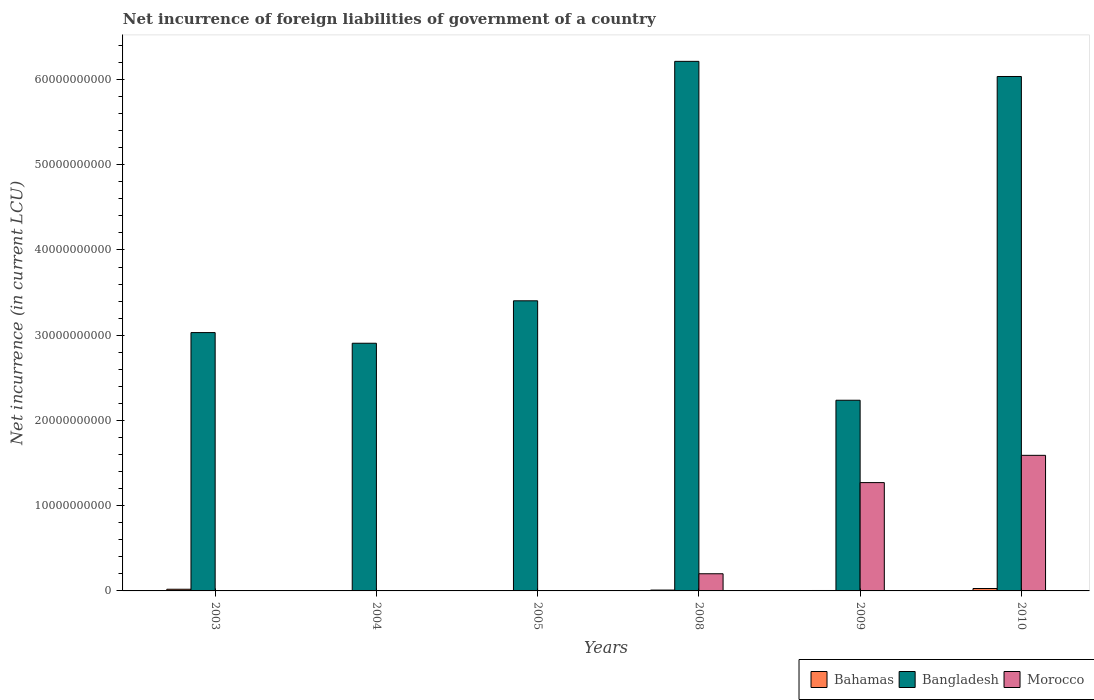Are the number of bars on each tick of the X-axis equal?
Your answer should be compact. No. How many bars are there on the 4th tick from the left?
Make the answer very short. 3. In how many cases, is the number of bars for a given year not equal to the number of legend labels?
Give a very brief answer. 3. What is the net incurrence of foreign liabilities in Bangladesh in 2010?
Make the answer very short. 6.04e+1. Across all years, what is the maximum net incurrence of foreign liabilities in Morocco?
Your answer should be compact. 1.59e+1. Across all years, what is the minimum net incurrence of foreign liabilities in Bahamas?
Your answer should be very brief. 0. What is the total net incurrence of foreign liabilities in Bangladesh in the graph?
Your response must be concise. 2.38e+11. What is the difference between the net incurrence of foreign liabilities in Bangladesh in 2004 and that in 2005?
Give a very brief answer. -4.98e+09. What is the difference between the net incurrence of foreign liabilities in Morocco in 2005 and the net incurrence of foreign liabilities in Bangladesh in 2009?
Ensure brevity in your answer.  -2.24e+1. What is the average net incurrence of foreign liabilities in Bangladesh per year?
Make the answer very short. 3.97e+1. In the year 2009, what is the difference between the net incurrence of foreign liabilities in Morocco and net incurrence of foreign liabilities in Bahamas?
Make the answer very short. 1.27e+1. What is the ratio of the net incurrence of foreign liabilities in Bangladesh in 2008 to that in 2009?
Your answer should be compact. 2.78. What is the difference between the highest and the second highest net incurrence of foreign liabilities in Morocco?
Your response must be concise. 3.20e+09. What is the difference between the highest and the lowest net incurrence of foreign liabilities in Bangladesh?
Provide a short and direct response. 3.98e+1. In how many years, is the net incurrence of foreign liabilities in Morocco greater than the average net incurrence of foreign liabilities in Morocco taken over all years?
Give a very brief answer. 2. Is the sum of the net incurrence of foreign liabilities in Bahamas in 2008 and 2010 greater than the maximum net incurrence of foreign liabilities in Bangladesh across all years?
Your answer should be compact. No. Are all the bars in the graph horizontal?
Make the answer very short. No. Does the graph contain any zero values?
Offer a very short reply. Yes. How many legend labels are there?
Provide a short and direct response. 3. What is the title of the graph?
Ensure brevity in your answer.  Net incurrence of foreign liabilities of government of a country. What is the label or title of the X-axis?
Your response must be concise. Years. What is the label or title of the Y-axis?
Keep it short and to the point. Net incurrence (in current LCU). What is the Net incurrence (in current LCU) in Bahamas in 2003?
Give a very brief answer. 1.97e+08. What is the Net incurrence (in current LCU) of Bangladesh in 2003?
Your answer should be compact. 3.03e+1. What is the Net incurrence (in current LCU) in Bahamas in 2004?
Ensure brevity in your answer.  0. What is the Net incurrence (in current LCU) in Bangladesh in 2004?
Your answer should be compact. 2.91e+1. What is the Net incurrence (in current LCU) of Morocco in 2004?
Your response must be concise. 0. What is the Net incurrence (in current LCU) of Bahamas in 2005?
Keep it short and to the point. 1.70e+06. What is the Net incurrence (in current LCU) of Bangladesh in 2005?
Keep it short and to the point. 3.40e+1. What is the Net incurrence (in current LCU) of Bangladesh in 2008?
Your response must be concise. 6.21e+1. What is the Net incurrence (in current LCU) of Morocco in 2008?
Make the answer very short. 2.01e+09. What is the Net incurrence (in current LCU) in Bahamas in 2009?
Your answer should be very brief. 5.02e+07. What is the Net incurrence (in current LCU) of Bangladesh in 2009?
Your response must be concise. 2.24e+1. What is the Net incurrence (in current LCU) in Morocco in 2009?
Offer a very short reply. 1.27e+1. What is the Net incurrence (in current LCU) of Bahamas in 2010?
Keep it short and to the point. 2.83e+08. What is the Net incurrence (in current LCU) of Bangladesh in 2010?
Give a very brief answer. 6.04e+1. What is the Net incurrence (in current LCU) in Morocco in 2010?
Your response must be concise. 1.59e+1. Across all years, what is the maximum Net incurrence (in current LCU) in Bahamas?
Your answer should be compact. 2.83e+08. Across all years, what is the maximum Net incurrence (in current LCU) in Bangladesh?
Offer a terse response. 6.21e+1. Across all years, what is the maximum Net incurrence (in current LCU) of Morocco?
Keep it short and to the point. 1.59e+1. Across all years, what is the minimum Net incurrence (in current LCU) in Bahamas?
Provide a succinct answer. 0. Across all years, what is the minimum Net incurrence (in current LCU) in Bangladesh?
Provide a short and direct response. 2.24e+1. What is the total Net incurrence (in current LCU) in Bahamas in the graph?
Make the answer very short. 6.32e+08. What is the total Net incurrence (in current LCU) of Bangladesh in the graph?
Keep it short and to the point. 2.38e+11. What is the total Net incurrence (in current LCU) in Morocco in the graph?
Ensure brevity in your answer.  3.06e+1. What is the difference between the Net incurrence (in current LCU) of Bangladesh in 2003 and that in 2004?
Provide a short and direct response. 1.25e+09. What is the difference between the Net incurrence (in current LCU) in Bahamas in 2003 and that in 2005?
Offer a very short reply. 1.95e+08. What is the difference between the Net incurrence (in current LCU) of Bangladesh in 2003 and that in 2005?
Make the answer very short. -3.73e+09. What is the difference between the Net incurrence (in current LCU) in Bahamas in 2003 and that in 2008?
Your response must be concise. 9.71e+07. What is the difference between the Net incurrence (in current LCU) in Bangladesh in 2003 and that in 2008?
Your response must be concise. -3.18e+1. What is the difference between the Net incurrence (in current LCU) in Bahamas in 2003 and that in 2009?
Give a very brief answer. 1.47e+08. What is the difference between the Net incurrence (in current LCU) in Bangladesh in 2003 and that in 2009?
Ensure brevity in your answer.  7.94e+09. What is the difference between the Net incurrence (in current LCU) in Bahamas in 2003 and that in 2010?
Your answer should be compact. -8.59e+07. What is the difference between the Net incurrence (in current LCU) in Bangladesh in 2003 and that in 2010?
Make the answer very short. -3.00e+1. What is the difference between the Net incurrence (in current LCU) of Bangladesh in 2004 and that in 2005?
Give a very brief answer. -4.98e+09. What is the difference between the Net incurrence (in current LCU) of Bangladesh in 2004 and that in 2008?
Your answer should be compact. -3.31e+1. What is the difference between the Net incurrence (in current LCU) in Bangladesh in 2004 and that in 2009?
Provide a succinct answer. 6.69e+09. What is the difference between the Net incurrence (in current LCU) in Bangladesh in 2004 and that in 2010?
Provide a succinct answer. -3.13e+1. What is the difference between the Net incurrence (in current LCU) of Bahamas in 2005 and that in 2008?
Provide a short and direct response. -9.83e+07. What is the difference between the Net incurrence (in current LCU) in Bangladesh in 2005 and that in 2008?
Ensure brevity in your answer.  -2.81e+1. What is the difference between the Net incurrence (in current LCU) of Bahamas in 2005 and that in 2009?
Your answer should be very brief. -4.85e+07. What is the difference between the Net incurrence (in current LCU) of Bangladesh in 2005 and that in 2009?
Keep it short and to the point. 1.17e+1. What is the difference between the Net incurrence (in current LCU) of Bahamas in 2005 and that in 2010?
Keep it short and to the point. -2.81e+08. What is the difference between the Net incurrence (in current LCU) of Bangladesh in 2005 and that in 2010?
Provide a short and direct response. -2.63e+1. What is the difference between the Net incurrence (in current LCU) in Bahamas in 2008 and that in 2009?
Offer a terse response. 4.98e+07. What is the difference between the Net incurrence (in current LCU) of Bangladesh in 2008 and that in 2009?
Give a very brief answer. 3.98e+1. What is the difference between the Net incurrence (in current LCU) of Morocco in 2008 and that in 2009?
Provide a short and direct response. -1.07e+1. What is the difference between the Net incurrence (in current LCU) in Bahamas in 2008 and that in 2010?
Provide a short and direct response. -1.83e+08. What is the difference between the Net incurrence (in current LCU) in Bangladesh in 2008 and that in 2010?
Give a very brief answer. 1.78e+09. What is the difference between the Net incurrence (in current LCU) of Morocco in 2008 and that in 2010?
Provide a succinct answer. -1.39e+1. What is the difference between the Net incurrence (in current LCU) of Bahamas in 2009 and that in 2010?
Your answer should be compact. -2.33e+08. What is the difference between the Net incurrence (in current LCU) of Bangladesh in 2009 and that in 2010?
Offer a very short reply. -3.80e+1. What is the difference between the Net incurrence (in current LCU) of Morocco in 2009 and that in 2010?
Your answer should be very brief. -3.20e+09. What is the difference between the Net incurrence (in current LCU) of Bahamas in 2003 and the Net incurrence (in current LCU) of Bangladesh in 2004?
Provide a succinct answer. -2.89e+1. What is the difference between the Net incurrence (in current LCU) of Bahamas in 2003 and the Net incurrence (in current LCU) of Bangladesh in 2005?
Your response must be concise. -3.38e+1. What is the difference between the Net incurrence (in current LCU) of Bahamas in 2003 and the Net incurrence (in current LCU) of Bangladesh in 2008?
Make the answer very short. -6.19e+1. What is the difference between the Net incurrence (in current LCU) of Bahamas in 2003 and the Net incurrence (in current LCU) of Morocco in 2008?
Your response must be concise. -1.82e+09. What is the difference between the Net incurrence (in current LCU) of Bangladesh in 2003 and the Net incurrence (in current LCU) of Morocco in 2008?
Give a very brief answer. 2.83e+1. What is the difference between the Net incurrence (in current LCU) of Bahamas in 2003 and the Net incurrence (in current LCU) of Bangladesh in 2009?
Keep it short and to the point. -2.22e+1. What is the difference between the Net incurrence (in current LCU) in Bahamas in 2003 and the Net incurrence (in current LCU) in Morocco in 2009?
Your answer should be compact. -1.25e+1. What is the difference between the Net incurrence (in current LCU) in Bangladesh in 2003 and the Net incurrence (in current LCU) in Morocco in 2009?
Make the answer very short. 1.76e+1. What is the difference between the Net incurrence (in current LCU) of Bahamas in 2003 and the Net incurrence (in current LCU) of Bangladesh in 2010?
Offer a terse response. -6.02e+1. What is the difference between the Net incurrence (in current LCU) of Bahamas in 2003 and the Net incurrence (in current LCU) of Morocco in 2010?
Give a very brief answer. -1.57e+1. What is the difference between the Net incurrence (in current LCU) of Bangladesh in 2003 and the Net incurrence (in current LCU) of Morocco in 2010?
Offer a terse response. 1.44e+1. What is the difference between the Net incurrence (in current LCU) of Bangladesh in 2004 and the Net incurrence (in current LCU) of Morocco in 2008?
Ensure brevity in your answer.  2.70e+1. What is the difference between the Net incurrence (in current LCU) in Bangladesh in 2004 and the Net incurrence (in current LCU) in Morocco in 2009?
Keep it short and to the point. 1.64e+1. What is the difference between the Net incurrence (in current LCU) of Bangladesh in 2004 and the Net incurrence (in current LCU) of Morocco in 2010?
Your answer should be very brief. 1.32e+1. What is the difference between the Net incurrence (in current LCU) in Bahamas in 2005 and the Net incurrence (in current LCU) in Bangladesh in 2008?
Your answer should be compact. -6.21e+1. What is the difference between the Net incurrence (in current LCU) in Bahamas in 2005 and the Net incurrence (in current LCU) in Morocco in 2008?
Ensure brevity in your answer.  -2.01e+09. What is the difference between the Net incurrence (in current LCU) of Bangladesh in 2005 and the Net incurrence (in current LCU) of Morocco in 2008?
Ensure brevity in your answer.  3.20e+1. What is the difference between the Net incurrence (in current LCU) of Bahamas in 2005 and the Net incurrence (in current LCU) of Bangladesh in 2009?
Make the answer very short. -2.24e+1. What is the difference between the Net incurrence (in current LCU) in Bahamas in 2005 and the Net incurrence (in current LCU) in Morocco in 2009?
Provide a short and direct response. -1.27e+1. What is the difference between the Net incurrence (in current LCU) in Bangladesh in 2005 and the Net incurrence (in current LCU) in Morocco in 2009?
Provide a short and direct response. 2.13e+1. What is the difference between the Net incurrence (in current LCU) in Bahamas in 2005 and the Net incurrence (in current LCU) in Bangladesh in 2010?
Keep it short and to the point. -6.04e+1. What is the difference between the Net incurrence (in current LCU) of Bahamas in 2005 and the Net incurrence (in current LCU) of Morocco in 2010?
Offer a very short reply. -1.59e+1. What is the difference between the Net incurrence (in current LCU) of Bangladesh in 2005 and the Net incurrence (in current LCU) of Morocco in 2010?
Keep it short and to the point. 1.81e+1. What is the difference between the Net incurrence (in current LCU) of Bahamas in 2008 and the Net incurrence (in current LCU) of Bangladesh in 2009?
Your response must be concise. -2.23e+1. What is the difference between the Net incurrence (in current LCU) in Bahamas in 2008 and the Net incurrence (in current LCU) in Morocco in 2009?
Provide a short and direct response. -1.26e+1. What is the difference between the Net incurrence (in current LCU) in Bangladesh in 2008 and the Net incurrence (in current LCU) in Morocco in 2009?
Provide a succinct answer. 4.94e+1. What is the difference between the Net incurrence (in current LCU) in Bahamas in 2008 and the Net incurrence (in current LCU) in Bangladesh in 2010?
Your response must be concise. -6.03e+1. What is the difference between the Net incurrence (in current LCU) in Bahamas in 2008 and the Net incurrence (in current LCU) in Morocco in 2010?
Provide a short and direct response. -1.58e+1. What is the difference between the Net incurrence (in current LCU) in Bangladesh in 2008 and the Net incurrence (in current LCU) in Morocco in 2010?
Your response must be concise. 4.62e+1. What is the difference between the Net incurrence (in current LCU) of Bahamas in 2009 and the Net incurrence (in current LCU) of Bangladesh in 2010?
Keep it short and to the point. -6.03e+1. What is the difference between the Net incurrence (in current LCU) in Bahamas in 2009 and the Net incurrence (in current LCU) in Morocco in 2010?
Give a very brief answer. -1.59e+1. What is the difference between the Net incurrence (in current LCU) in Bangladesh in 2009 and the Net incurrence (in current LCU) in Morocco in 2010?
Offer a terse response. 6.46e+09. What is the average Net incurrence (in current LCU) in Bahamas per year?
Make the answer very short. 1.05e+08. What is the average Net incurrence (in current LCU) in Bangladesh per year?
Keep it short and to the point. 3.97e+1. What is the average Net incurrence (in current LCU) of Morocco per year?
Keep it short and to the point. 5.10e+09. In the year 2003, what is the difference between the Net incurrence (in current LCU) in Bahamas and Net incurrence (in current LCU) in Bangladesh?
Provide a succinct answer. -3.01e+1. In the year 2005, what is the difference between the Net incurrence (in current LCU) in Bahamas and Net incurrence (in current LCU) in Bangladesh?
Make the answer very short. -3.40e+1. In the year 2008, what is the difference between the Net incurrence (in current LCU) of Bahamas and Net incurrence (in current LCU) of Bangladesh?
Provide a short and direct response. -6.20e+1. In the year 2008, what is the difference between the Net incurrence (in current LCU) of Bahamas and Net incurrence (in current LCU) of Morocco?
Your answer should be very brief. -1.91e+09. In the year 2008, what is the difference between the Net incurrence (in current LCU) of Bangladesh and Net incurrence (in current LCU) of Morocco?
Ensure brevity in your answer.  6.01e+1. In the year 2009, what is the difference between the Net incurrence (in current LCU) in Bahamas and Net incurrence (in current LCU) in Bangladesh?
Give a very brief answer. -2.23e+1. In the year 2009, what is the difference between the Net incurrence (in current LCU) of Bahamas and Net incurrence (in current LCU) of Morocco?
Offer a very short reply. -1.27e+1. In the year 2009, what is the difference between the Net incurrence (in current LCU) in Bangladesh and Net incurrence (in current LCU) in Morocco?
Give a very brief answer. 9.66e+09. In the year 2010, what is the difference between the Net incurrence (in current LCU) in Bahamas and Net incurrence (in current LCU) in Bangladesh?
Provide a short and direct response. -6.01e+1. In the year 2010, what is the difference between the Net incurrence (in current LCU) of Bahamas and Net incurrence (in current LCU) of Morocco?
Offer a very short reply. -1.56e+1. In the year 2010, what is the difference between the Net incurrence (in current LCU) of Bangladesh and Net incurrence (in current LCU) of Morocco?
Provide a succinct answer. 4.44e+1. What is the ratio of the Net incurrence (in current LCU) of Bangladesh in 2003 to that in 2004?
Your answer should be compact. 1.04. What is the ratio of the Net incurrence (in current LCU) in Bahamas in 2003 to that in 2005?
Your answer should be very brief. 115.94. What is the ratio of the Net incurrence (in current LCU) in Bangladesh in 2003 to that in 2005?
Your answer should be very brief. 0.89. What is the ratio of the Net incurrence (in current LCU) in Bahamas in 2003 to that in 2008?
Your response must be concise. 1.97. What is the ratio of the Net incurrence (in current LCU) in Bangladesh in 2003 to that in 2008?
Keep it short and to the point. 0.49. What is the ratio of the Net incurrence (in current LCU) of Bahamas in 2003 to that in 2009?
Your answer should be very brief. 3.93. What is the ratio of the Net incurrence (in current LCU) in Bangladesh in 2003 to that in 2009?
Your answer should be compact. 1.35. What is the ratio of the Net incurrence (in current LCU) in Bahamas in 2003 to that in 2010?
Keep it short and to the point. 0.7. What is the ratio of the Net incurrence (in current LCU) in Bangladesh in 2003 to that in 2010?
Make the answer very short. 0.5. What is the ratio of the Net incurrence (in current LCU) in Bangladesh in 2004 to that in 2005?
Provide a succinct answer. 0.85. What is the ratio of the Net incurrence (in current LCU) of Bangladesh in 2004 to that in 2008?
Provide a short and direct response. 0.47. What is the ratio of the Net incurrence (in current LCU) in Bangladesh in 2004 to that in 2009?
Provide a short and direct response. 1.3. What is the ratio of the Net incurrence (in current LCU) in Bangladesh in 2004 to that in 2010?
Offer a very short reply. 0.48. What is the ratio of the Net incurrence (in current LCU) in Bahamas in 2005 to that in 2008?
Offer a very short reply. 0.02. What is the ratio of the Net incurrence (in current LCU) of Bangladesh in 2005 to that in 2008?
Your response must be concise. 0.55. What is the ratio of the Net incurrence (in current LCU) of Bahamas in 2005 to that in 2009?
Your response must be concise. 0.03. What is the ratio of the Net incurrence (in current LCU) of Bangladesh in 2005 to that in 2009?
Your answer should be very brief. 1.52. What is the ratio of the Net incurrence (in current LCU) in Bahamas in 2005 to that in 2010?
Give a very brief answer. 0.01. What is the ratio of the Net incurrence (in current LCU) of Bangladesh in 2005 to that in 2010?
Ensure brevity in your answer.  0.56. What is the ratio of the Net incurrence (in current LCU) of Bahamas in 2008 to that in 2009?
Provide a succinct answer. 1.99. What is the ratio of the Net incurrence (in current LCU) of Bangladesh in 2008 to that in 2009?
Provide a succinct answer. 2.78. What is the ratio of the Net incurrence (in current LCU) in Morocco in 2008 to that in 2009?
Offer a terse response. 0.16. What is the ratio of the Net incurrence (in current LCU) in Bahamas in 2008 to that in 2010?
Ensure brevity in your answer.  0.35. What is the ratio of the Net incurrence (in current LCU) in Bangladesh in 2008 to that in 2010?
Your answer should be very brief. 1.03. What is the ratio of the Net incurrence (in current LCU) in Morocco in 2008 to that in 2010?
Give a very brief answer. 0.13. What is the ratio of the Net incurrence (in current LCU) of Bahamas in 2009 to that in 2010?
Provide a succinct answer. 0.18. What is the ratio of the Net incurrence (in current LCU) of Bangladesh in 2009 to that in 2010?
Ensure brevity in your answer.  0.37. What is the ratio of the Net incurrence (in current LCU) of Morocco in 2009 to that in 2010?
Your answer should be compact. 0.8. What is the difference between the highest and the second highest Net incurrence (in current LCU) in Bahamas?
Give a very brief answer. 8.59e+07. What is the difference between the highest and the second highest Net incurrence (in current LCU) of Bangladesh?
Your answer should be very brief. 1.78e+09. What is the difference between the highest and the second highest Net incurrence (in current LCU) in Morocco?
Make the answer very short. 3.20e+09. What is the difference between the highest and the lowest Net incurrence (in current LCU) in Bahamas?
Keep it short and to the point. 2.83e+08. What is the difference between the highest and the lowest Net incurrence (in current LCU) of Bangladesh?
Keep it short and to the point. 3.98e+1. What is the difference between the highest and the lowest Net incurrence (in current LCU) in Morocco?
Ensure brevity in your answer.  1.59e+1. 